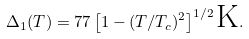<formula> <loc_0><loc_0><loc_500><loc_500>\Delta _ { 1 } ( T ) = 7 7 \left [ 1 - ( T / T _ { c } ) ^ { 2 } \right ] ^ { 1 / 2 } \text {K} .</formula> 